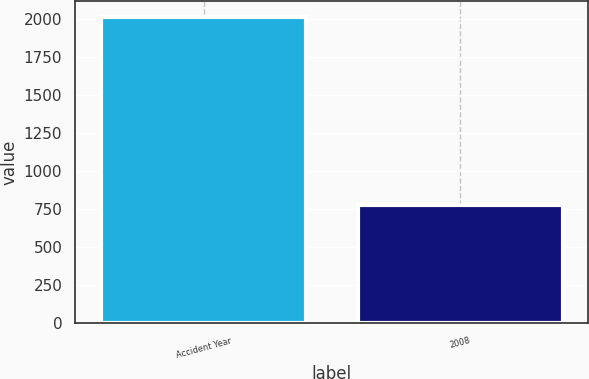Convert chart. <chart><loc_0><loc_0><loc_500><loc_500><bar_chart><fcel>Accident Year<fcel>2008<nl><fcel>2014<fcel>777<nl></chart> 